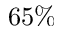<formula> <loc_0><loc_0><loc_500><loc_500>6 5 \%</formula> 